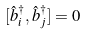Convert formula to latex. <formula><loc_0><loc_0><loc_500><loc_500>[ \hat { b } _ { i } ^ { \dagger } , \hat { b } _ { j } ^ { \dagger } ] = 0</formula> 